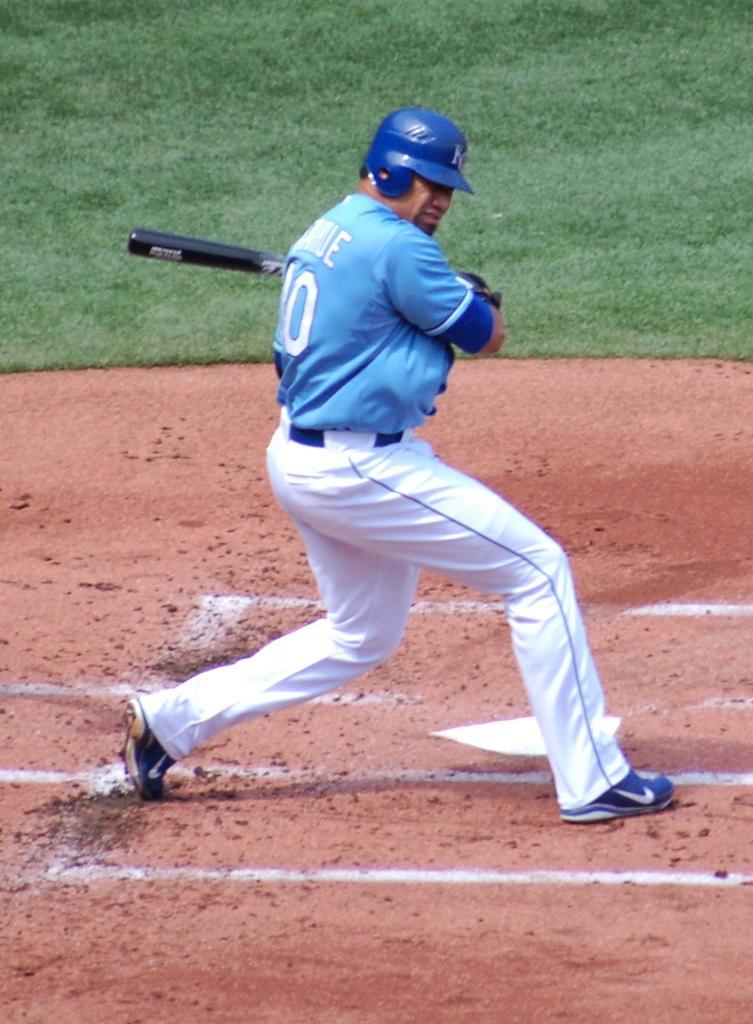Can you describe this image briefly? In this picture I can see a person wearing a helmet and holding a baseball bat and standing on the surface. I can see green grass. 